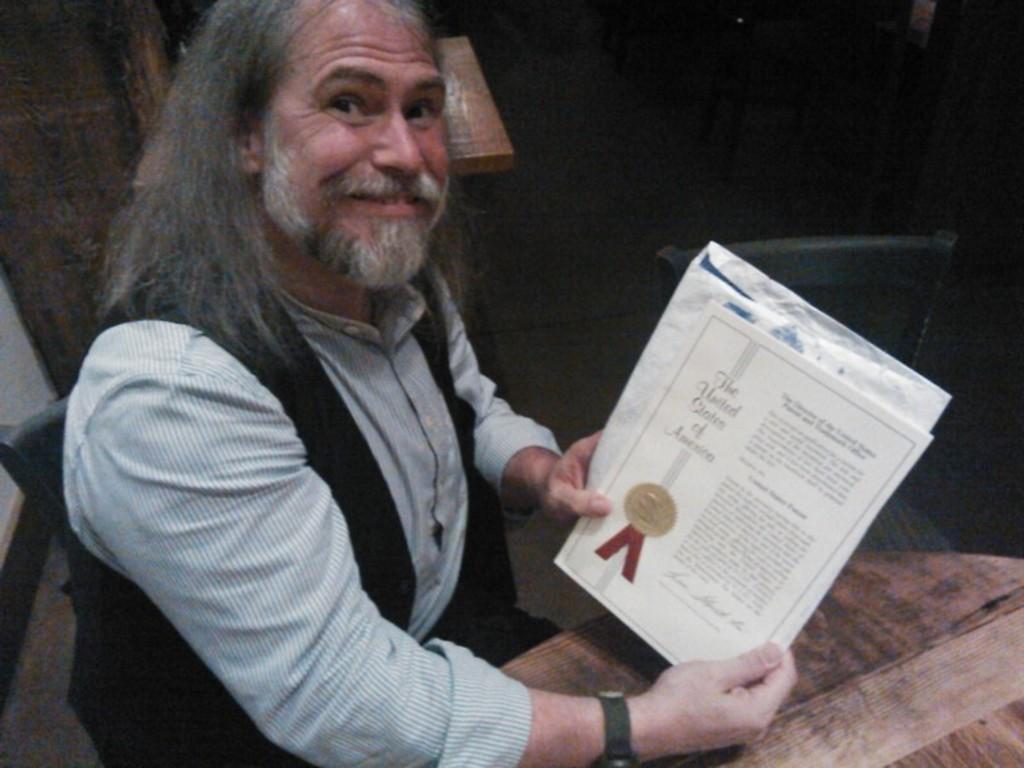Describe this image in one or two sentences. In this image we can see a man sitting and holding a certificate in his hand, before him there is a table. In the background we can see a chair and a wall. 